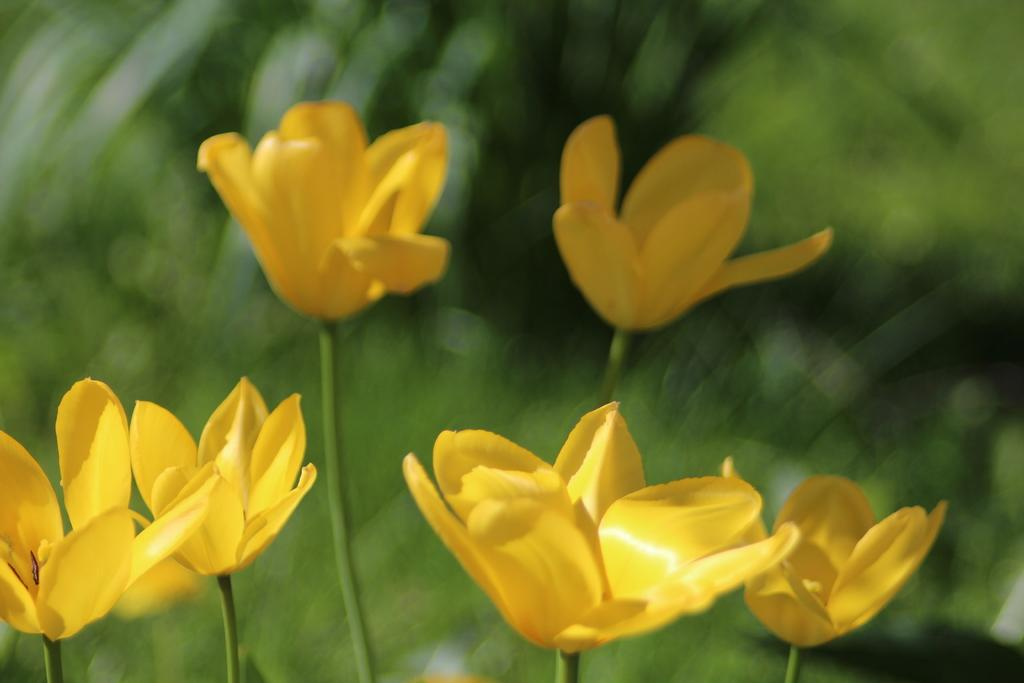What type of flowers are present in the image? There are yellow flowers with stems in the image. What can be seen in the background of the image? The background of the image is green and blurred. Who is the owner of the clover in the image? There is no clover present in the image, and therefore no owner can be identified. What type of apparatus is being used to capture the image? The facts provided do not give any information about the apparatus used to capture the image. 